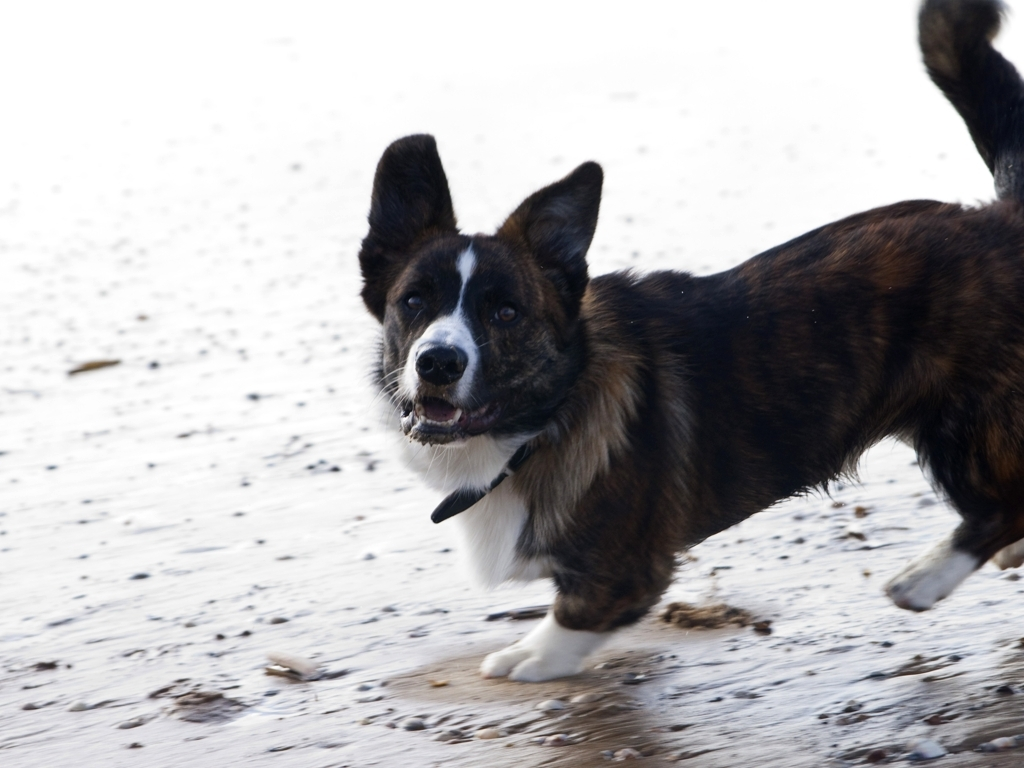What is the dog doing in this picture? The dog appears to be in mid-run, possibly playing or chasing after something, as evident by its open mouth, focus, and the dynamic position of its legs. 